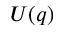Convert formula to latex. <formula><loc_0><loc_0><loc_500><loc_500>U ( q )</formula> 